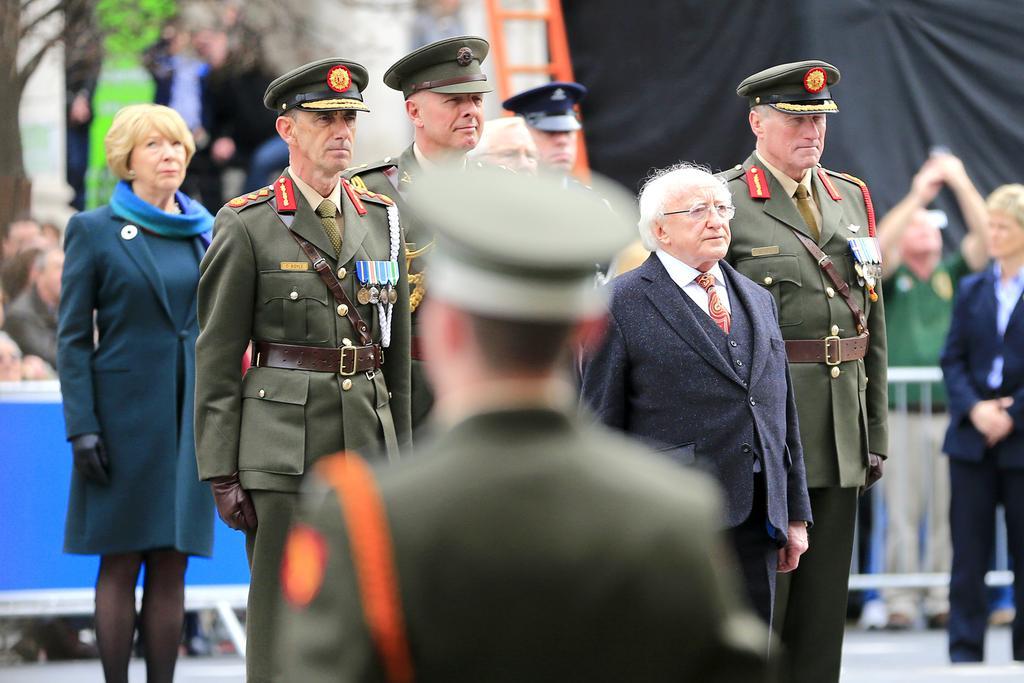Can you describe this image briefly? In the center of the image we can see people standing. There is a fence. In the background there is a tree and a curtain. 